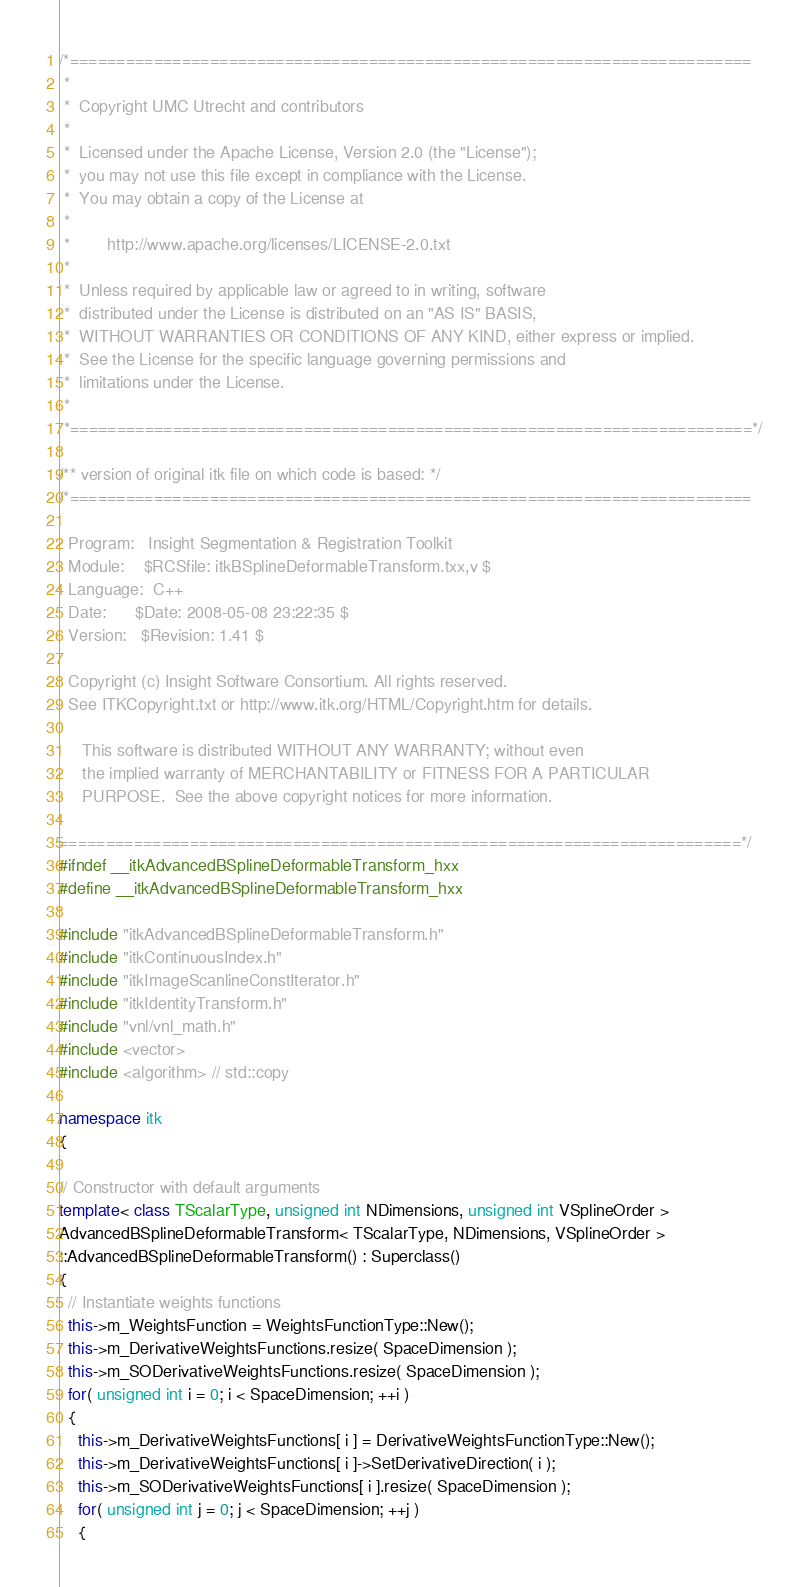<code> <loc_0><loc_0><loc_500><loc_500><_C++_>/*=========================================================================
 *
 *  Copyright UMC Utrecht and contributors
 *
 *  Licensed under the Apache License, Version 2.0 (the "License");
 *  you may not use this file except in compliance with the License.
 *  You may obtain a copy of the License at
 *
 *        http://www.apache.org/licenses/LICENSE-2.0.txt
 *
 *  Unless required by applicable law or agreed to in writing, software
 *  distributed under the License is distributed on an "AS IS" BASIS,
 *  WITHOUT WARRANTIES OR CONDITIONS OF ANY KIND, either express or implied.
 *  See the License for the specific language governing permissions and
 *  limitations under the License.
 *
 *=========================================================================*/

/** version of original itk file on which code is based: */
/*=========================================================================

  Program:   Insight Segmentation & Registration Toolkit
  Module:    $RCSfile: itkBSplineDeformableTransform.txx,v $
  Language:  C++
  Date:      $Date: 2008-05-08 23:22:35 $
  Version:   $Revision: 1.41 $

  Copyright (c) Insight Software Consortium. All rights reserved.
  See ITKCopyright.txt or http://www.itk.org/HTML/Copyright.htm for details.

     This software is distributed WITHOUT ANY WARRANTY; without even
     the implied warranty of MERCHANTABILITY or FITNESS FOR A PARTICULAR
     PURPOSE.  See the above copyright notices for more information.

=========================================================================*/
#ifndef __itkAdvancedBSplineDeformableTransform_hxx
#define __itkAdvancedBSplineDeformableTransform_hxx

#include "itkAdvancedBSplineDeformableTransform.h"
#include "itkContinuousIndex.h"
#include "itkImageScanlineConstIterator.h"
#include "itkIdentityTransform.h"
#include "vnl/vnl_math.h"
#include <vector>
#include <algorithm> // std::copy

namespace itk
{

// Constructor with default arguments
template< class TScalarType, unsigned int NDimensions, unsigned int VSplineOrder >
AdvancedBSplineDeformableTransform< TScalarType, NDimensions, VSplineOrder >
::AdvancedBSplineDeformableTransform() : Superclass()
{
  // Instantiate weights functions
  this->m_WeightsFunction = WeightsFunctionType::New();
  this->m_DerivativeWeightsFunctions.resize( SpaceDimension );
  this->m_SODerivativeWeightsFunctions.resize( SpaceDimension );
  for( unsigned int i = 0; i < SpaceDimension; ++i )
  {
    this->m_DerivativeWeightsFunctions[ i ] = DerivativeWeightsFunctionType::New();
    this->m_DerivativeWeightsFunctions[ i ]->SetDerivativeDirection( i );
    this->m_SODerivativeWeightsFunctions[ i ].resize( SpaceDimension );
    for( unsigned int j = 0; j < SpaceDimension; ++j )
    {</code> 